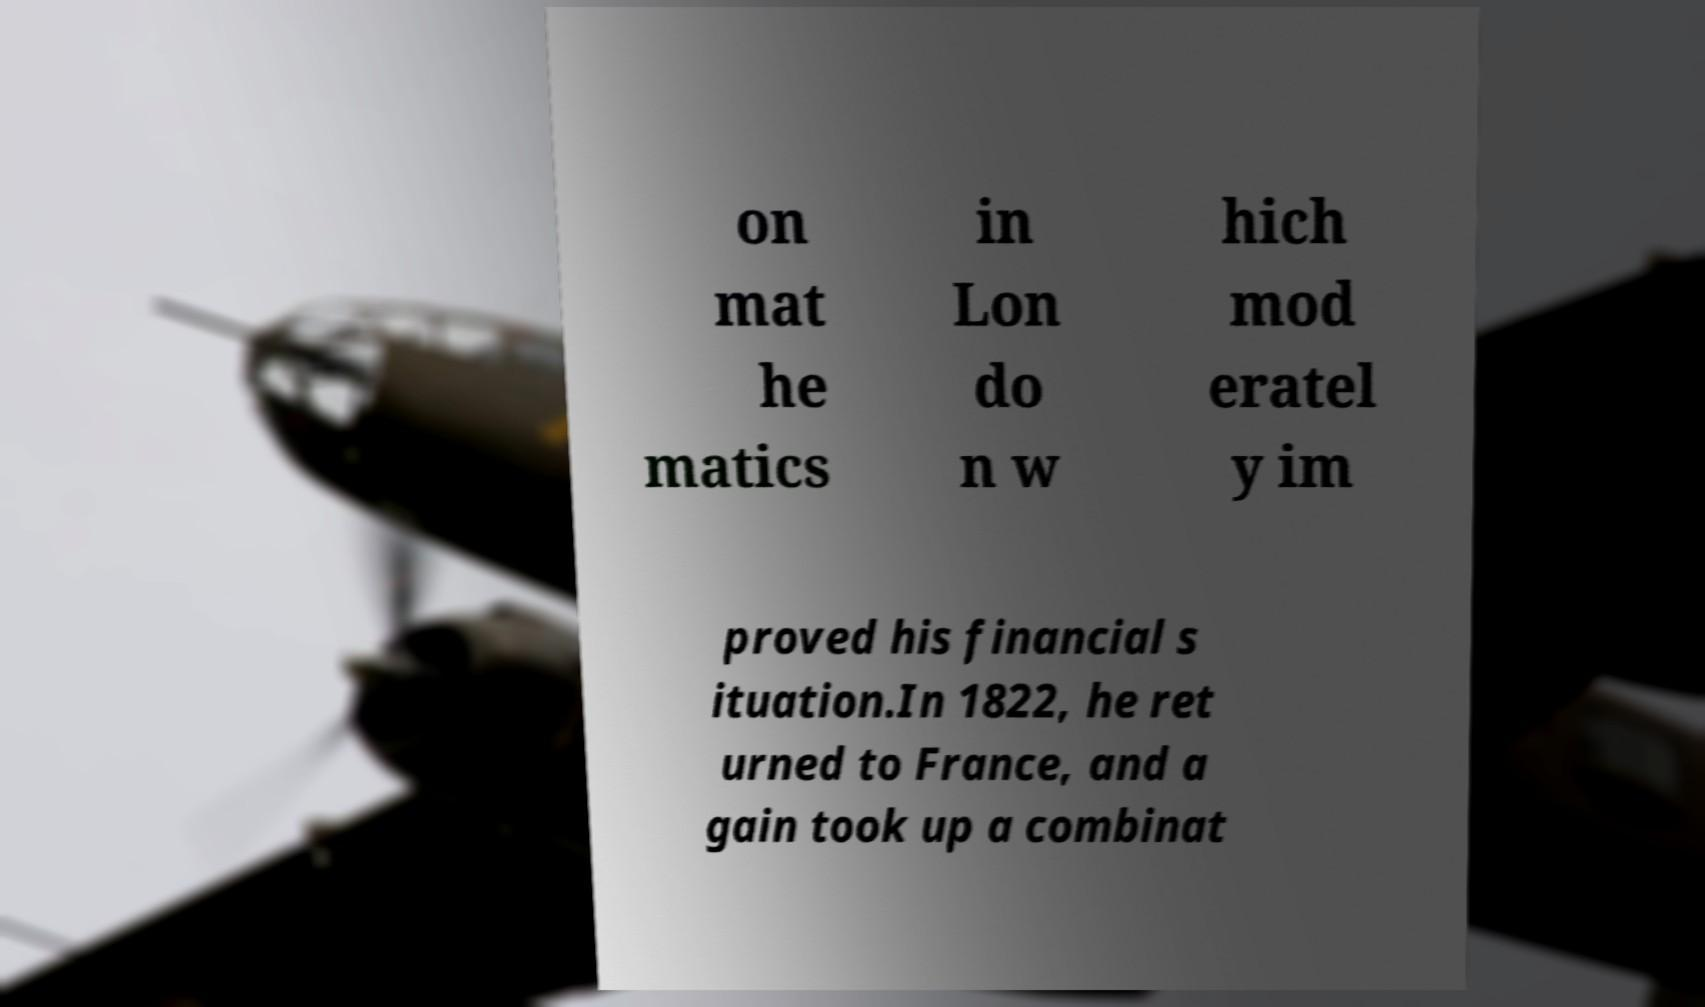There's text embedded in this image that I need extracted. Can you transcribe it verbatim? on mat he matics in Lon do n w hich mod eratel y im proved his financial s ituation.In 1822, he ret urned to France, and a gain took up a combinat 